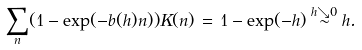Convert formula to latex. <formula><loc_0><loc_0><loc_500><loc_500>\sum _ { n } ( 1 - \exp ( - b ( h ) n ) ) K ( n ) \, = \, 1 - \exp ( - h ) \stackrel { h \searrow 0 } \sim h .</formula> 